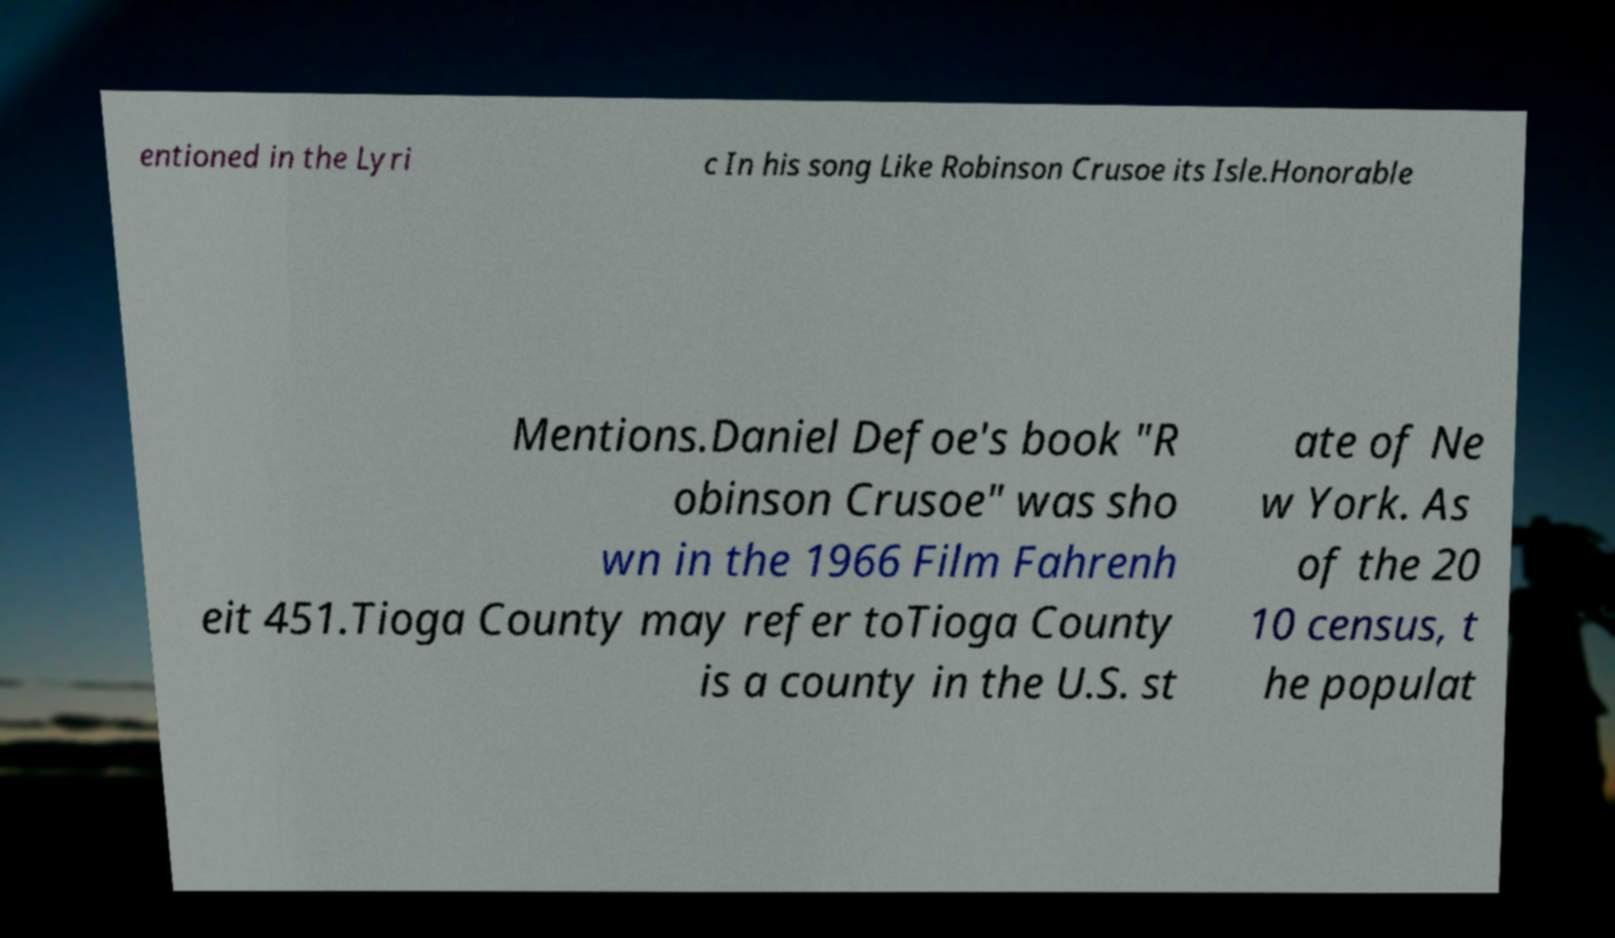Could you assist in decoding the text presented in this image and type it out clearly? entioned in the Lyri c In his song Like Robinson Crusoe its Isle.Honorable Mentions.Daniel Defoe's book "R obinson Crusoe" was sho wn in the 1966 Film Fahrenh eit 451.Tioga County may refer toTioga County is a county in the U.S. st ate of Ne w York. As of the 20 10 census, t he populat 